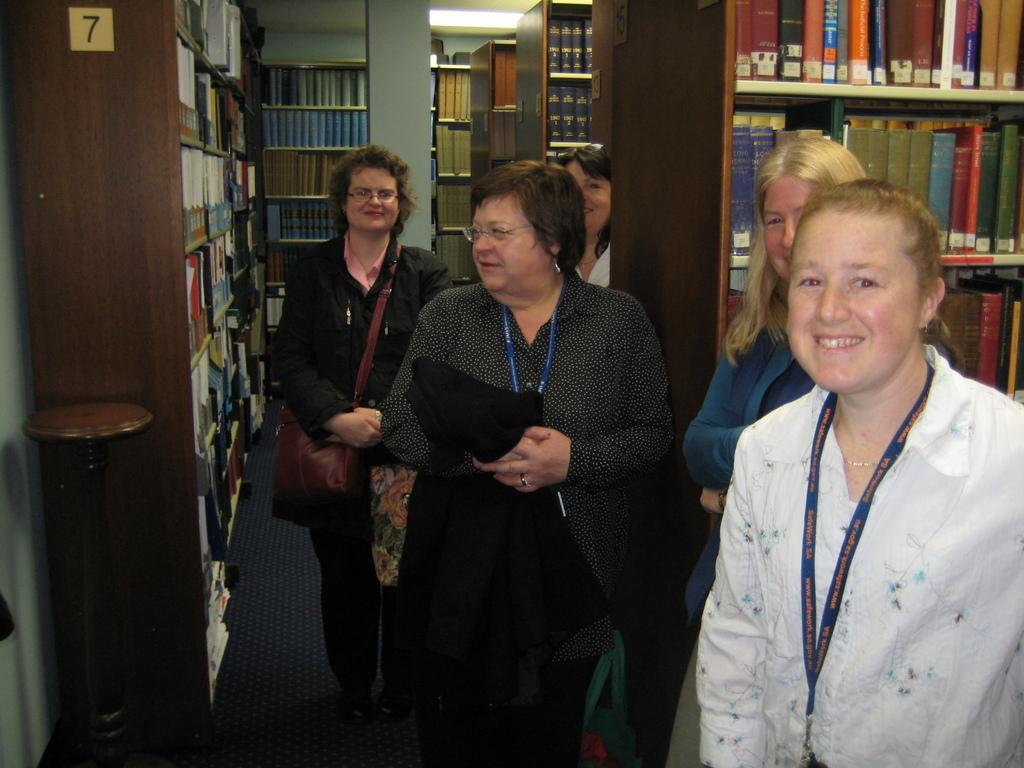In one or two sentences, can you explain what this image depicts? In the center of the image there are five ladies. In the background of the image there are bookshelves. To the right side of the image there is a bookshelf. 